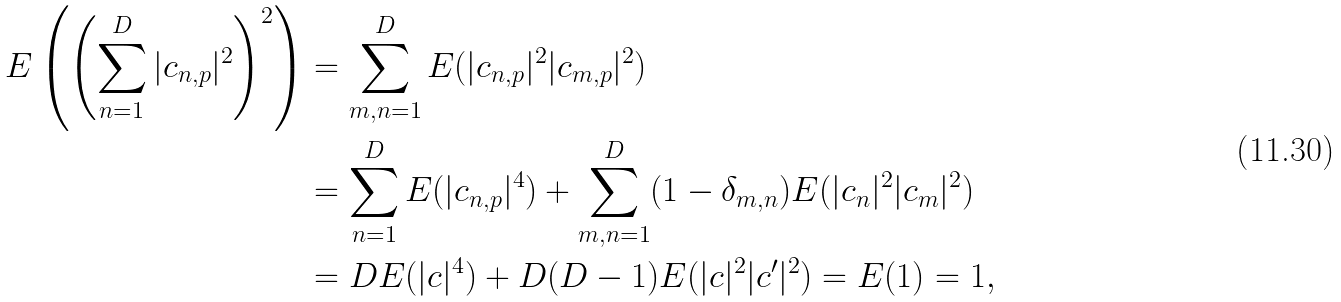Convert formula to latex. <formula><loc_0><loc_0><loc_500><loc_500>E \left ( \left ( \sum _ { n = 1 } ^ { D } | c _ { n , p } | ^ { 2 } \right ) ^ { 2 } \right ) & = \sum _ { m , n = 1 } ^ { D } E ( | c _ { n , p } | ^ { 2 } | c _ { m , p } | ^ { 2 } ) \\ & = \sum _ { n = 1 } ^ { D } E ( | c _ { n , p } | ^ { 4 } ) + \sum _ { m , n = 1 } ^ { D } ( 1 - \delta _ { m , n } ) E ( | c _ { n } | ^ { 2 } | c _ { m } | ^ { 2 } ) \\ & = D E ( | c | ^ { 4 } ) + D ( D - 1 ) E ( | c | ^ { 2 } | c ^ { \prime } | ^ { 2 } ) = E ( 1 ) = 1 ,</formula> 